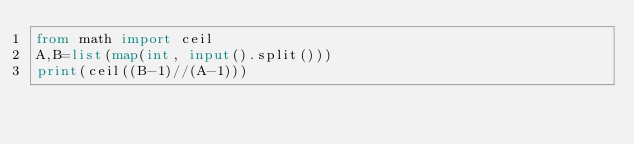Convert code to text. <code><loc_0><loc_0><loc_500><loc_500><_Python_>from math import ceil
A,B=list(map(int, input().split()))
print(ceil((B-1)//(A-1)))</code> 